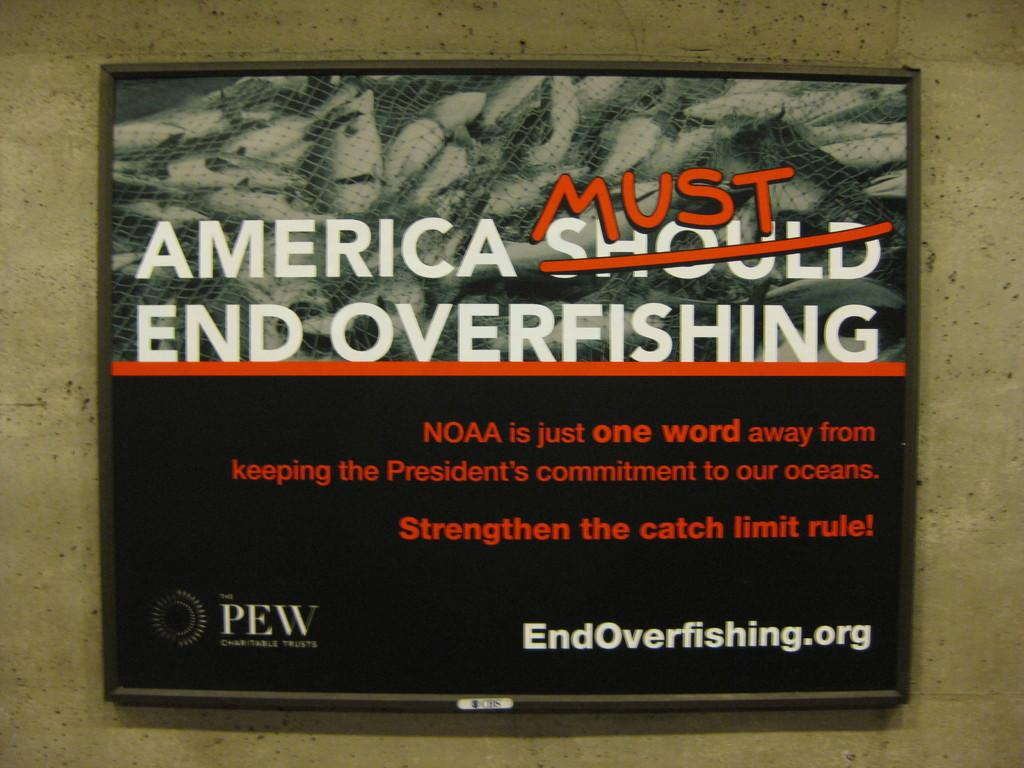<image>
Give a short and clear explanation of the subsequent image. A large framed poster hangs on a ceramic wall explaining why America must end overfishing. 